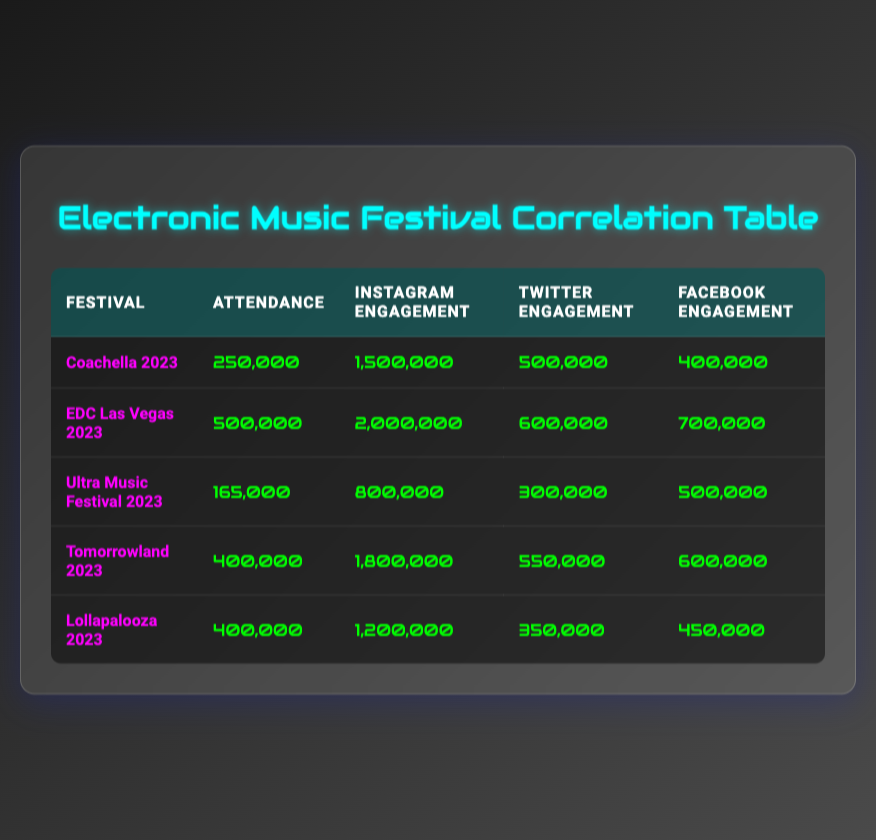What is the total attendance for all festivals listed? To find the total attendance, we need to sum up the attendance values from each festival: 250,000 (Coachella) + 500,000 (EDC Las Vegas) + 165,000 (Ultra Music Festival) + 400,000 (Tomorrowland) + 400,000 (Lollapalooza) = 1,715,000.
Answer: 1,715,000 Is the Instagram engagement for Tomorrowland greater than that for Coachella? Tomorrowland has an Instagram engagement of 1,800,000, while Coachella has 1,500,000. Since 1,800,000 is greater than 1,500,000, the statement is true.
Answer: Yes What is the average Twitter engagement across all festivals? To find the average Twitter engagement, we sum all Twitter engagement values: 500,000 (Coachella) + 600,000 (EDC Las Vegas) + 300,000 (Ultra Music Festival) + 550,000 (Tomorrowland) + 350,000 (Lollapalooza) = 2,300,000. We then divide by the number of festivals (5): 2,300,000 / 5 = 460,000.
Answer: 460,000 Which festival has the highest Facebook engagement? Looking through the Facebook engagement column, we see the values: 400,000 (Coachella), 700,000 (EDC Las Vegas), 500,000 (Ultra Music Festival), 600,000 (Tomorrowland), and 450,000 (Lollapalooza). EDC Las Vegas has the highest value of 700,000.
Answer: EDC Las Vegas 2023 Is the attendance for Ultra Music Festival higher than the average attendance of all festivals? First, we find the average attendance. The total attendance is 1,715,000 (calculated earlier), and there are 5 festivals, so the average attendance is 1,715,000 / 5 = 343,000. Ultra Music Festival has an attendance of 165,000, which is less than 343,000. Therefore, the answer is false.
Answer: No 